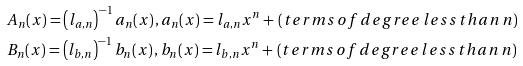<formula> <loc_0><loc_0><loc_500><loc_500>& A _ { n } ( x ) = \left ( l _ { a , n } \right ) ^ { - 1 } a _ { n } ( x ) \, , a _ { n } ( x ) = l _ { a , n } x ^ { n } + \, ( t e r m s \, o f \, d e g r e e \, l e s s \, t h a n \, n ) \\ & B _ { n } ( x ) = \left ( l _ { b , n } \right ) ^ { - 1 } b _ { n } ( x ) \, , b _ { n } ( x ) = l _ { b , n } x ^ { n } + \, ( t e r m s \, o f \, d e g r e e \, l e s s \, t h a n \, n )</formula> 